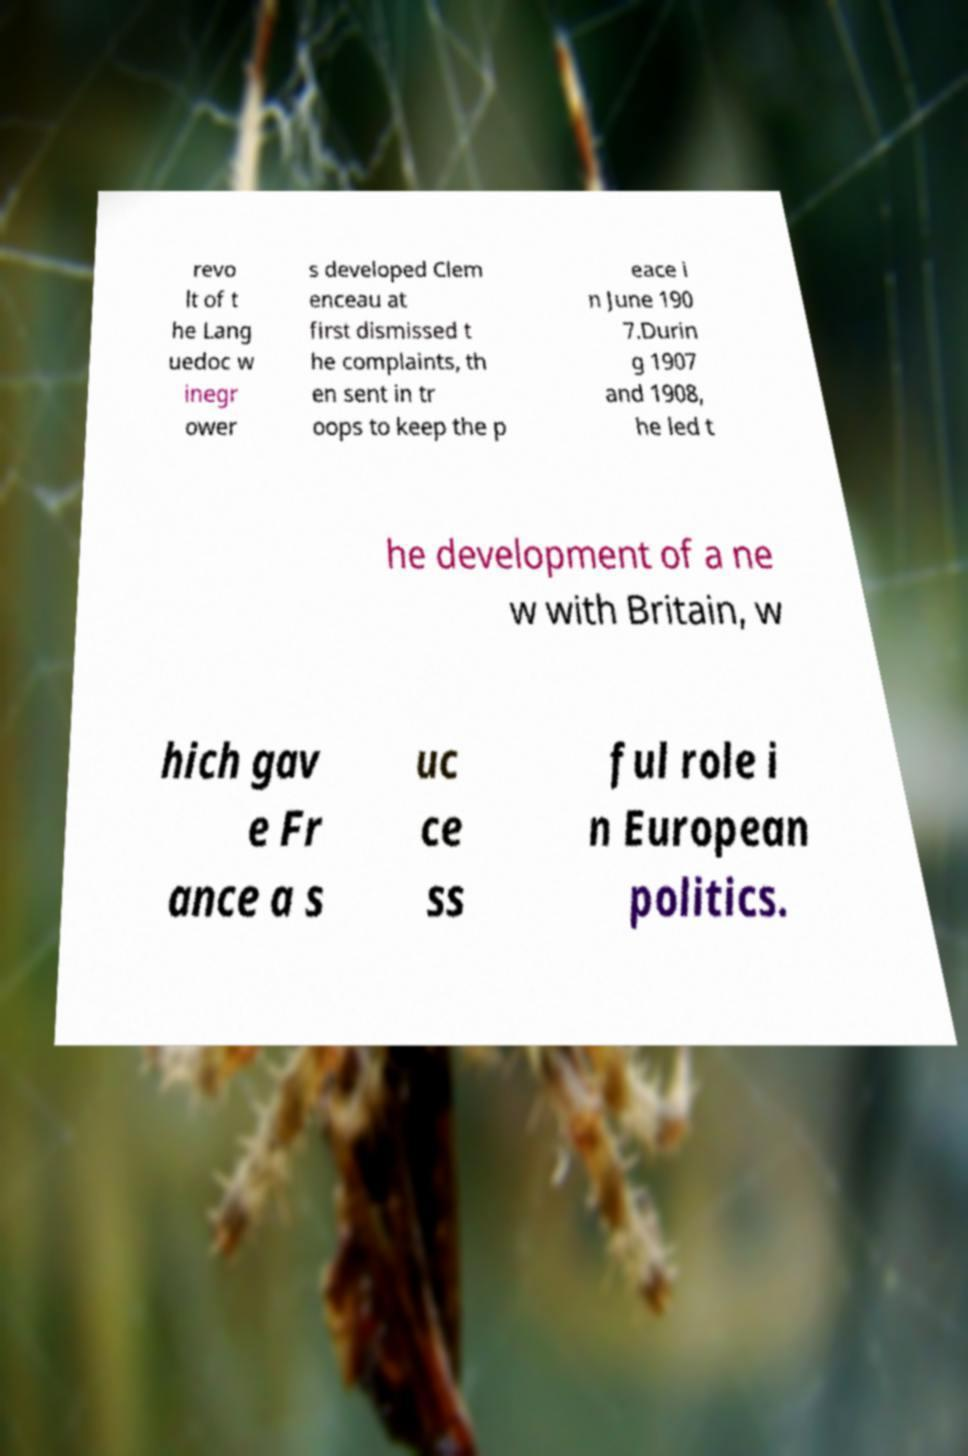What messages or text are displayed in this image? I need them in a readable, typed format. revo lt of t he Lang uedoc w inegr ower s developed Clem enceau at first dismissed t he complaints, th en sent in tr oops to keep the p eace i n June 190 7.Durin g 1907 and 1908, he led t he development of a ne w with Britain, w hich gav e Fr ance a s uc ce ss ful role i n European politics. 